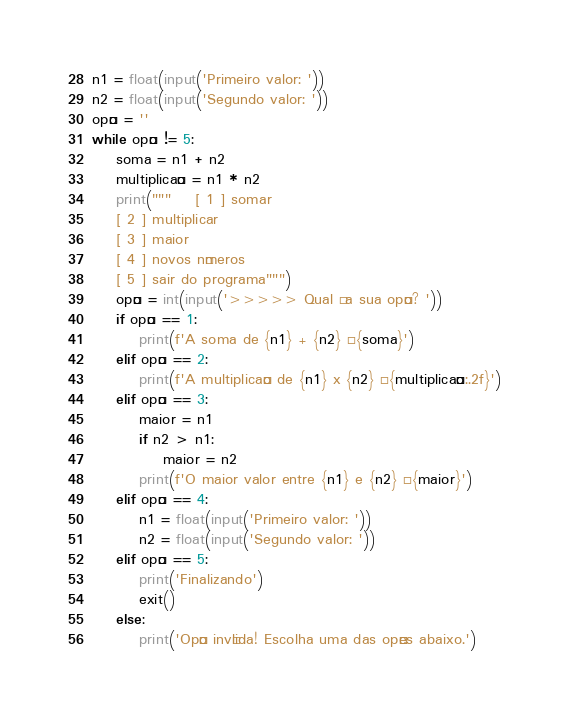Convert code to text. <code><loc_0><loc_0><loc_500><loc_500><_Python_>n1 = float(input('Primeiro valor: '))
n2 = float(input('Segundo valor: '))
opção = ''
while opção != 5:
    soma = n1 + n2
    multiplicação = n1 * n2
    print("""    [ 1 ] somar
    [ 2 ] multiplicar
    [ 3 ] maior
    [ 4 ] novos números
    [ 5 ] sair do programa""")
    opção = int(input('>>>>> Qual é a sua opção? '))
    if opção == 1:
        print(f'A soma de {n1} + {n2} é {soma}')
    elif opção == 2:
        print(f'A multiplicação de {n1} x {n2} é {multiplicação:.2f}')
    elif opção == 3:
        maior = n1
        if n2 > n1:
            maior = n2
        print(f'O maior valor entre {n1} e {n2} é {maior}')
    elif opção == 4:
        n1 = float(input('Primeiro valor: '))
        n2 = float(input('Segundo valor: '))
    elif opção == 5:
        print('Finalizando')
        exit()
    else:
        print('Opção inválida! Escolha uma das opções abaixo.')
</code> 